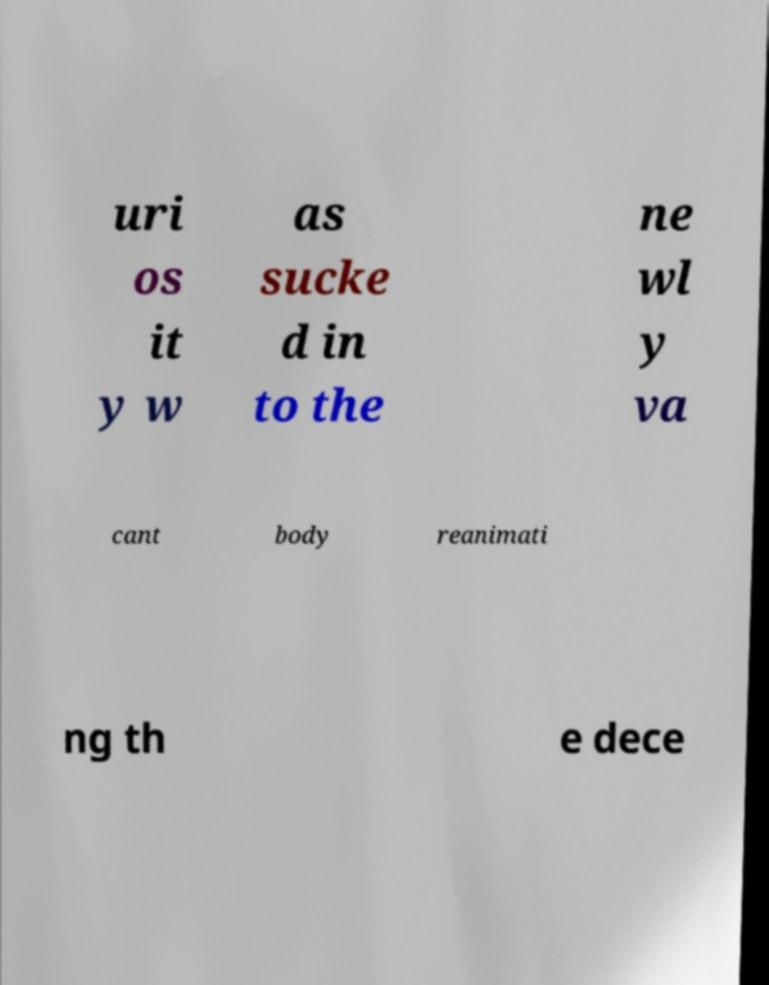What messages or text are displayed in this image? I need them in a readable, typed format. uri os it y w as sucke d in to the ne wl y va cant body reanimati ng th e dece 